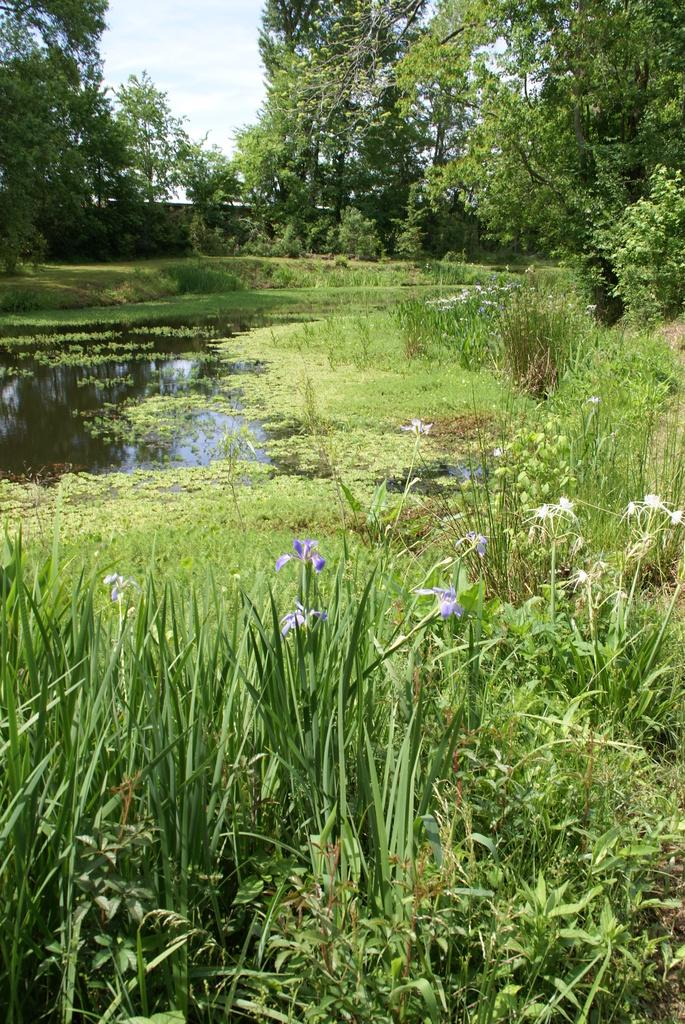What types of vegetation can be seen at the bottom of the image? There are plants, flowers, and grass at the bottom of the image. What body of water is present at the bottom of the image? There is a small pond at the bottom of the image. What can be seen in the background of the image? There are trees and a wall in the background of the image. What part of the natural environment is visible at the top of the image? The sky is visible at the top of the image. How many sheep are blowing in the wind in the image? There are no sheep present in the image, nor is there any blowing in the wind. 